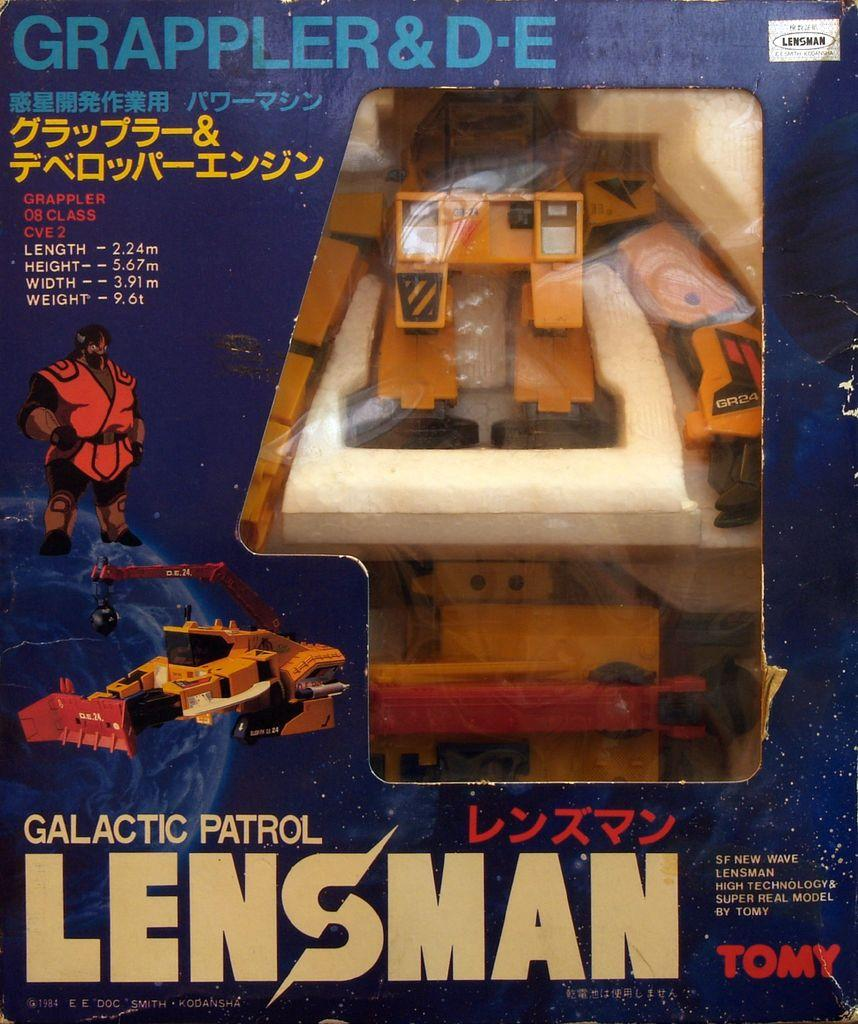<image>
Present a compact description of the photo's key features. A Galactic Patrol Lensman toy made by Tomy 